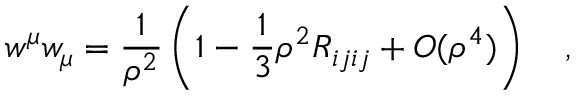Convert formula to latex. <formula><loc_0><loc_0><loc_500><loc_500>w ^ { \mu } w _ { \mu } = { \frac { 1 } { \rho ^ { 2 } } } \left ( 1 - \frac { 1 } { 3 } \rho ^ { 2 } R _ { i j i j } + O ( \rho ^ { 4 } ) \right ) ,</formula> 